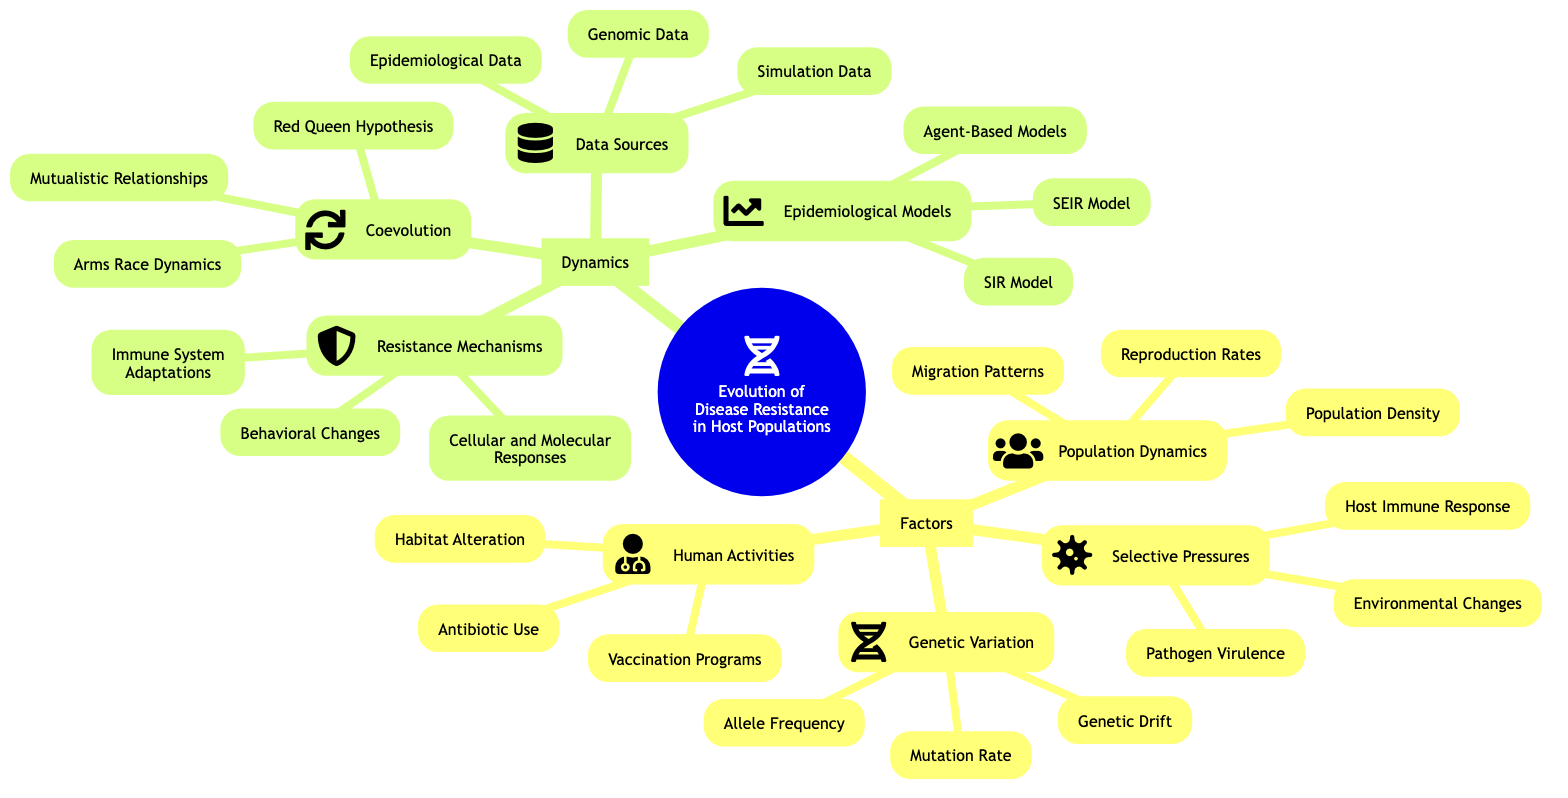What are the four main factors affecting the evolution of disease resistance? The diagram indicates that the four main factors are Genetic Variation, Selective Pressures, Population Dynamics, and Human Activities. This can be found under the "Factors" node in the concept map.
Answer: Genetic Variation, Selective Pressures, Population Dynamics, Human Activities How many components are listed under Selective Pressures? By examining the "Selective Pressures" node in the map, it shows three components: Pathogen Virulence, Host Immune Response, and Environmental Changes. Thus, the total is three.
Answer: 3 What are the resistance mechanisms mentioned in the dynamics section? Looking at the "Resistance Mechanisms" node, it lists three mechanisms: Behavioral Changes, Immune System Adaptations, and Cellular and Molecular Responses. These are the components directly connected to that node.
Answer: Behavioral Changes, Immune System Adaptations, Cellular and Molecular Responses How does coevolution relate to resistance in host populations? The "Coevolution" section includes Arms Race Dynamics, Red Queen Hypothesis, and Mutualistic Relationships. These factors suggest how hosts and pathogens evolve together, influencing resistance. Each of these aspects contributes to understanding coevolution in disease resistance.
Answer: Arms Race Dynamics, Red Queen Hypothesis, Mutualistic Relationships Which epidemiological model is included in the dynamics section? The diagram lists three epidemiological models under the "Epidemiological Models" node, specifically: SIR Model, SEIR Model, and Agent-Based Models. Thus, any of these can be used to study disease dynamics.
Answer: SIR Model, SEIR Model, Agent-Based Models What type of data sources are identified for studying disease resistance? The "Data Sources" node includes three different types: Genomic Data, Epidemiological Data, and Simulation Data. These sources are essential for analysis in disease resistance research.
Answer: Genomic Data, Epidemiological Data, Simulation Data What selective pressure directly relates to the interaction of host immune systems and pathogen virulence? Under "Selective Pressures", "Host Immune Response" directly interacts with "Pathogen Virulence," suggesting that the immune response in hosts can drive the evolutionary changes in pathogen virulence. This relationship describes a key aspect of disease resistance dynamics.
Answer: Host Immune Response How many factors are connected to Genetic Variation? The "Genetic Variation" node branches into three factors: Allele Frequency, Mutation Rate, and Genetic Drift. By counting these, we find that there are three factors connected to Genetic Variation in the diagram.
Answer: 3 